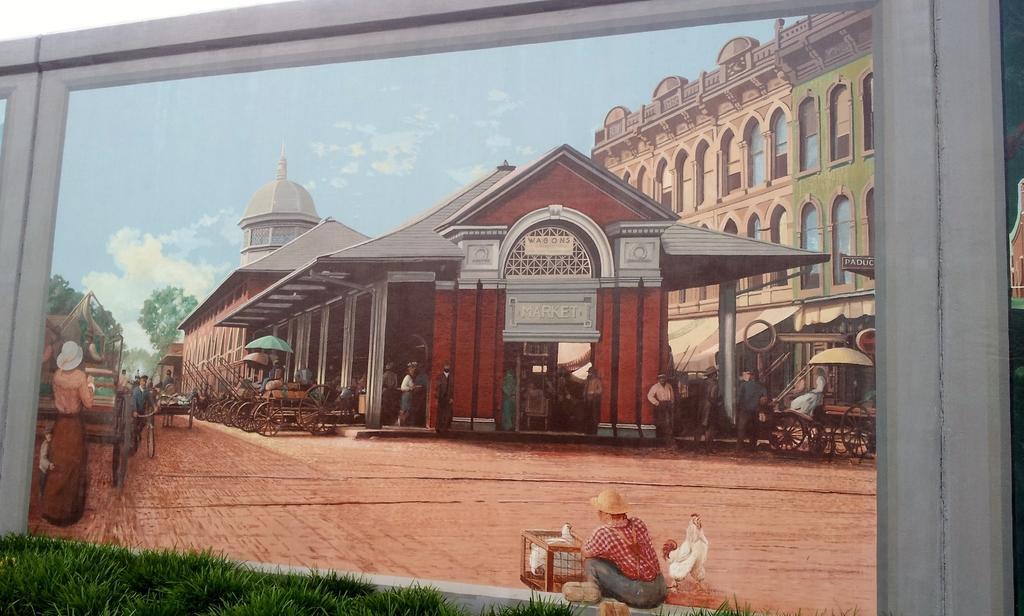How would you summarize this image in a sentence or two? In the picture we can see a frame with painting of a house and pillars to it and near to it we can see a man sitting on the path wearing a hat and beside him we can see some things are placed and beside the house we can see a building and sky with clouds. 